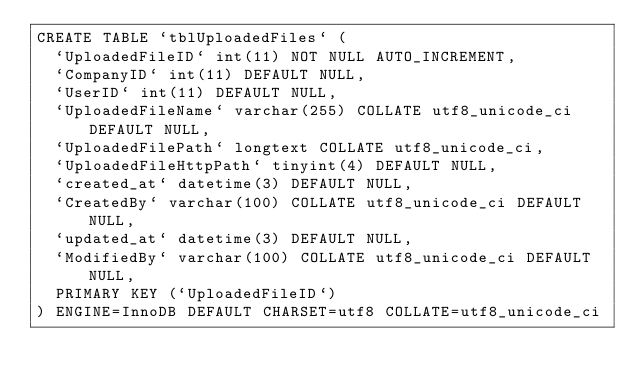Convert code to text. <code><loc_0><loc_0><loc_500><loc_500><_SQL_>CREATE TABLE `tblUploadedFiles` (
  `UploadedFileID` int(11) NOT NULL AUTO_INCREMENT,
  `CompanyID` int(11) DEFAULT NULL,
  `UserID` int(11) DEFAULT NULL,
  `UploadedFileName` varchar(255) COLLATE utf8_unicode_ci DEFAULT NULL,
  `UploadedFilePath` longtext COLLATE utf8_unicode_ci,
  `UploadedFileHttpPath` tinyint(4) DEFAULT NULL,
  `created_at` datetime(3) DEFAULT NULL,
  `CreatedBy` varchar(100) COLLATE utf8_unicode_ci DEFAULT NULL,
  `updated_at` datetime(3) DEFAULT NULL,
  `ModifiedBy` varchar(100) COLLATE utf8_unicode_ci DEFAULT NULL,
  PRIMARY KEY (`UploadedFileID`)
) ENGINE=InnoDB DEFAULT CHARSET=utf8 COLLATE=utf8_unicode_ci</code> 